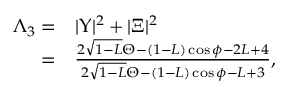Convert formula to latex. <formula><loc_0><loc_0><loc_500><loc_500>\begin{array} { r l } { \Lambda _ { 3 } = } & | \Upsilon | ^ { 2 } + | \Xi | ^ { 2 } } \\ { = } & \frac { 2 \sqrt { 1 - L } \Theta - ( 1 - L ) \cos \phi - 2 L + 4 } { 2 \sqrt { 1 - L } \Theta - ( 1 - L ) \cos \phi - L + 3 } , } \end{array}</formula> 